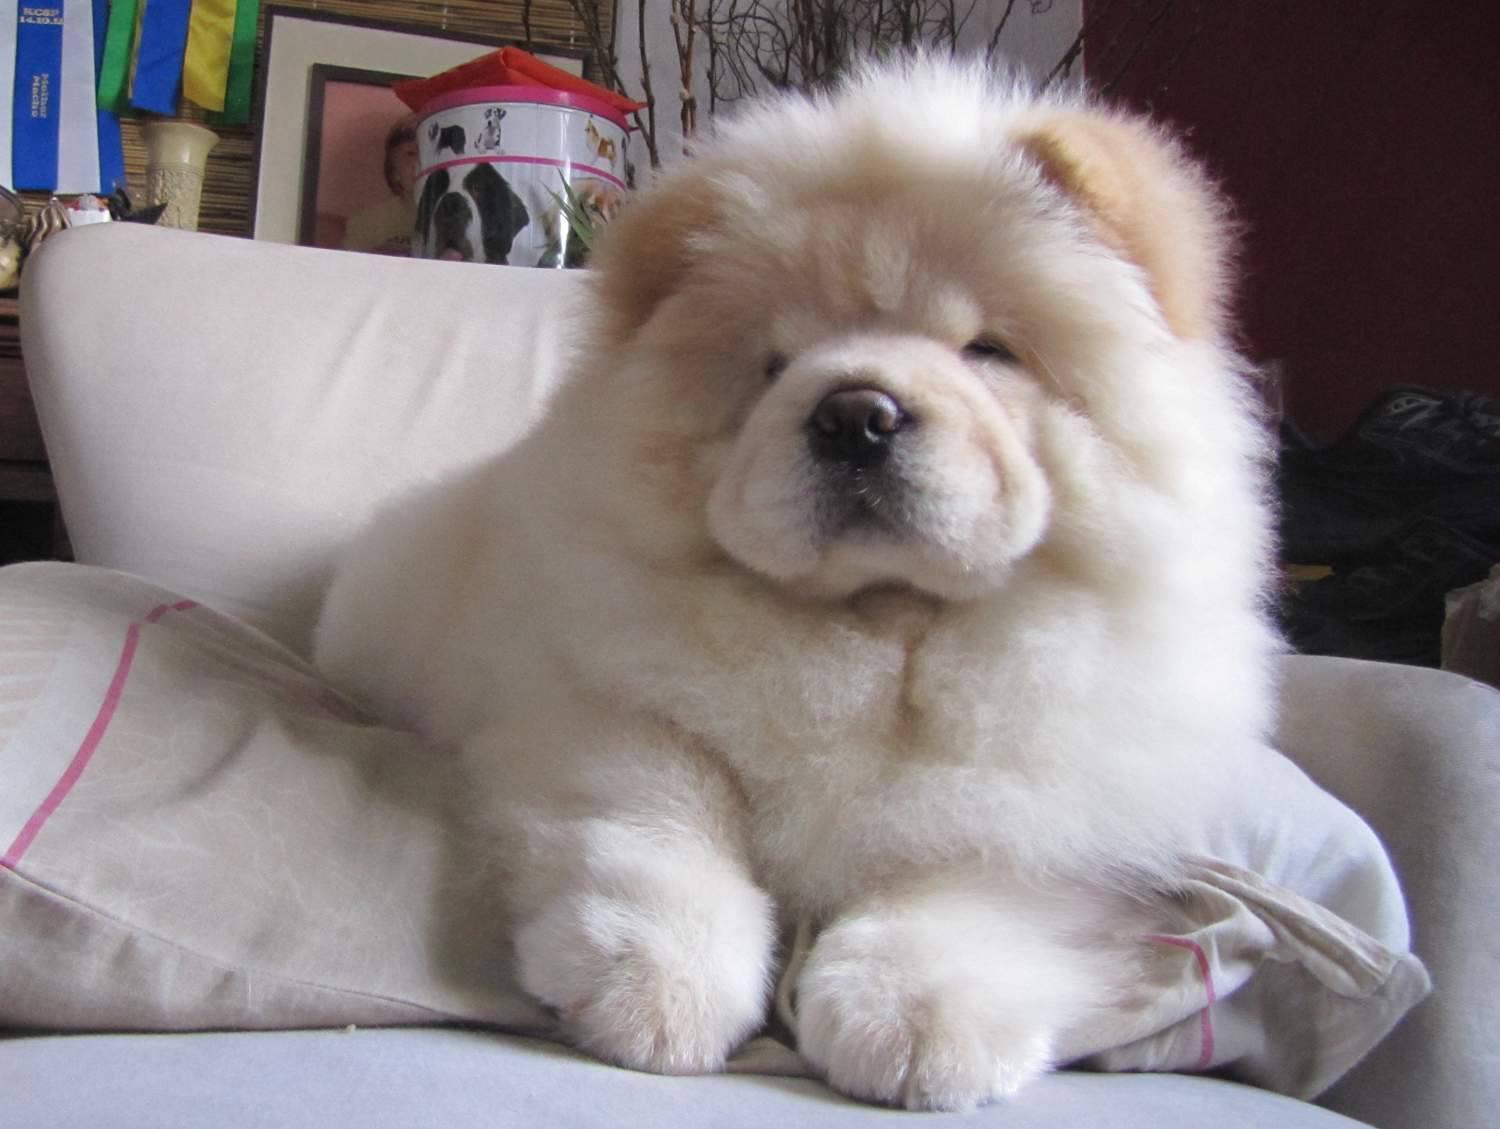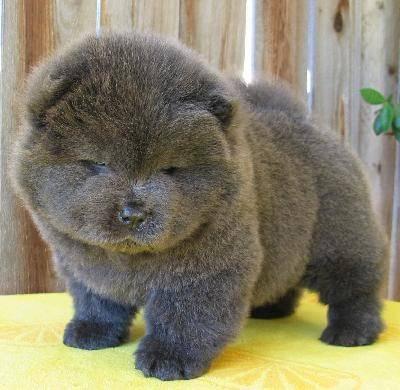The first image is the image on the left, the second image is the image on the right. Considering the images on both sides, is "Each image contains exactly one chow pup, and the pup that has darker, non-blond fur is standing on all fours." valid? Answer yes or no. Yes. The first image is the image on the left, the second image is the image on the right. Given the left and right images, does the statement "One of the images features a dog laying down." hold true? Answer yes or no. Yes. 